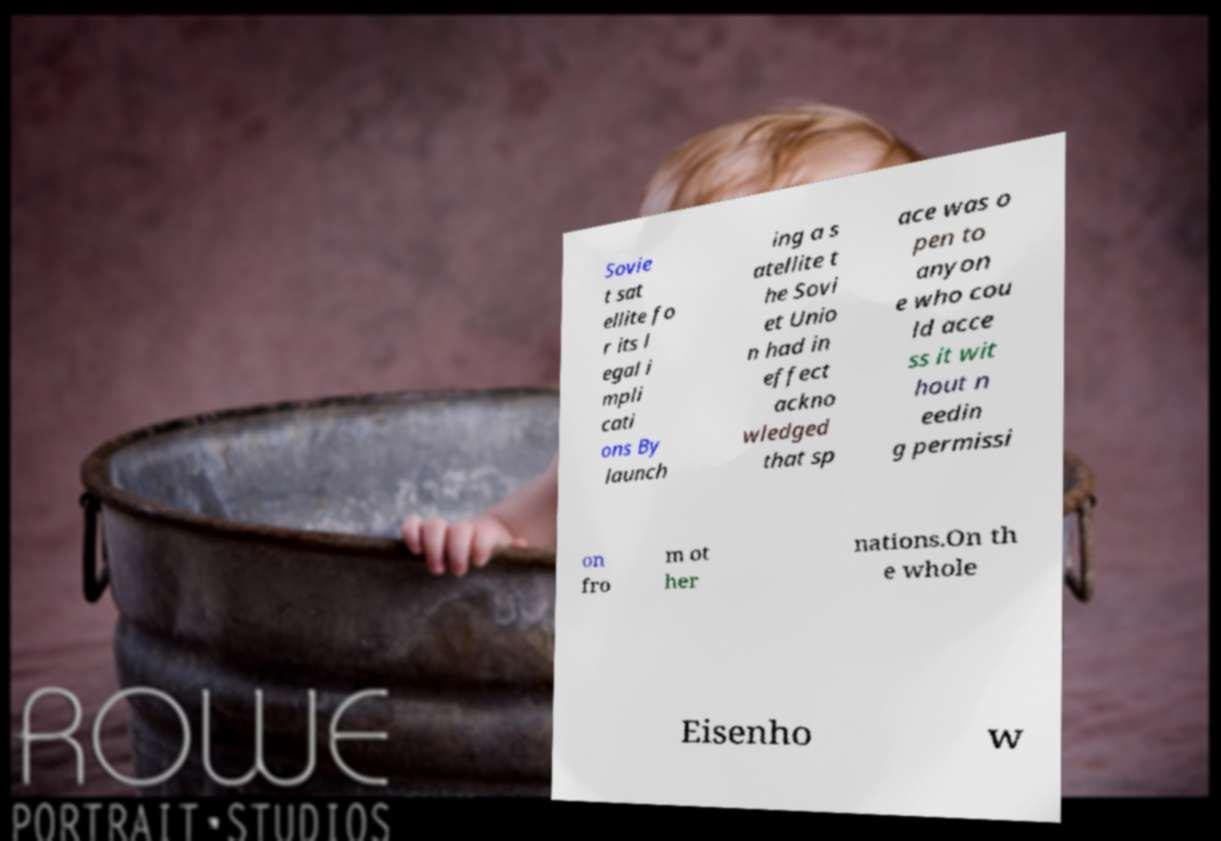Could you assist in decoding the text presented in this image and type it out clearly? Sovie t sat ellite fo r its l egal i mpli cati ons By launch ing a s atellite t he Sovi et Unio n had in effect ackno wledged that sp ace was o pen to anyon e who cou ld acce ss it wit hout n eedin g permissi on fro m ot her nations.On th e whole Eisenho w 